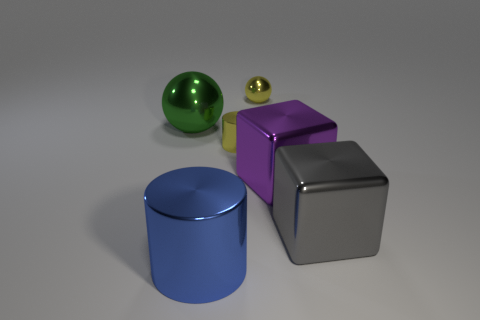Add 1 big cyan matte cylinders. How many objects exist? 7 Subtract all balls. How many objects are left? 4 Add 6 small yellow balls. How many small yellow balls exist? 7 Subtract 1 blue cylinders. How many objects are left? 5 Subtract all large cylinders. Subtract all big spheres. How many objects are left? 4 Add 3 small yellow metal objects. How many small yellow metal objects are left? 5 